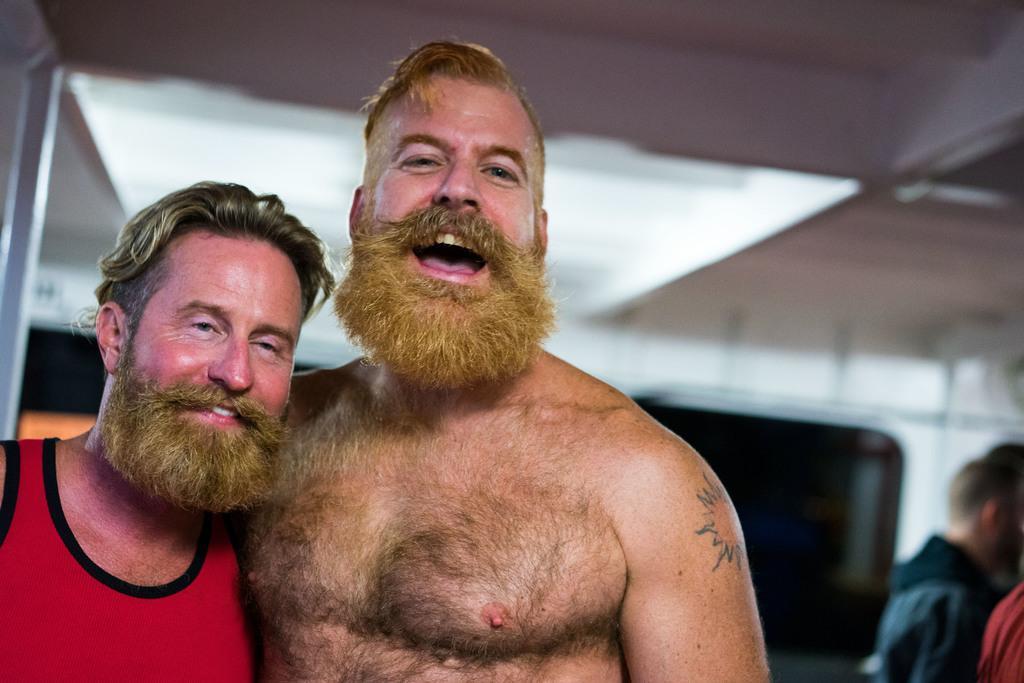Could you give a brief overview of what you see in this image? On the left side of the image we can see two persons are standing and a man is shouting. In the background of the image we can see the wall and windows. On the right side of the image we can see some persons are standing. At the top of the image we can see the roof. 